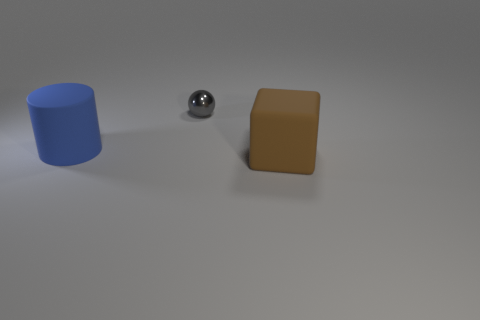What is the thing that is on the left side of the big brown thing and in front of the shiny sphere made of?
Ensure brevity in your answer.  Rubber. Do the tiny thing and the large blue object have the same material?
Offer a terse response. No. What size is the thing that is both right of the big blue rubber object and behind the rubber block?
Your answer should be compact. Small. The brown object is what shape?
Provide a succinct answer. Cube. What number of objects are yellow rubber blocks or large objects that are to the left of the brown matte thing?
Ensure brevity in your answer.  1. The object that is in front of the tiny shiny thing and to the right of the big blue rubber object is what color?
Your answer should be compact. Brown. There is a object that is behind the big blue cylinder; what is its material?
Keep it short and to the point. Metal. The rubber cube has what size?
Offer a terse response. Large. How many red objects are either big cylinders or large matte cubes?
Your response must be concise. 0. There is a rubber object right of the matte thing that is to the left of the block; how big is it?
Offer a terse response. Large. 